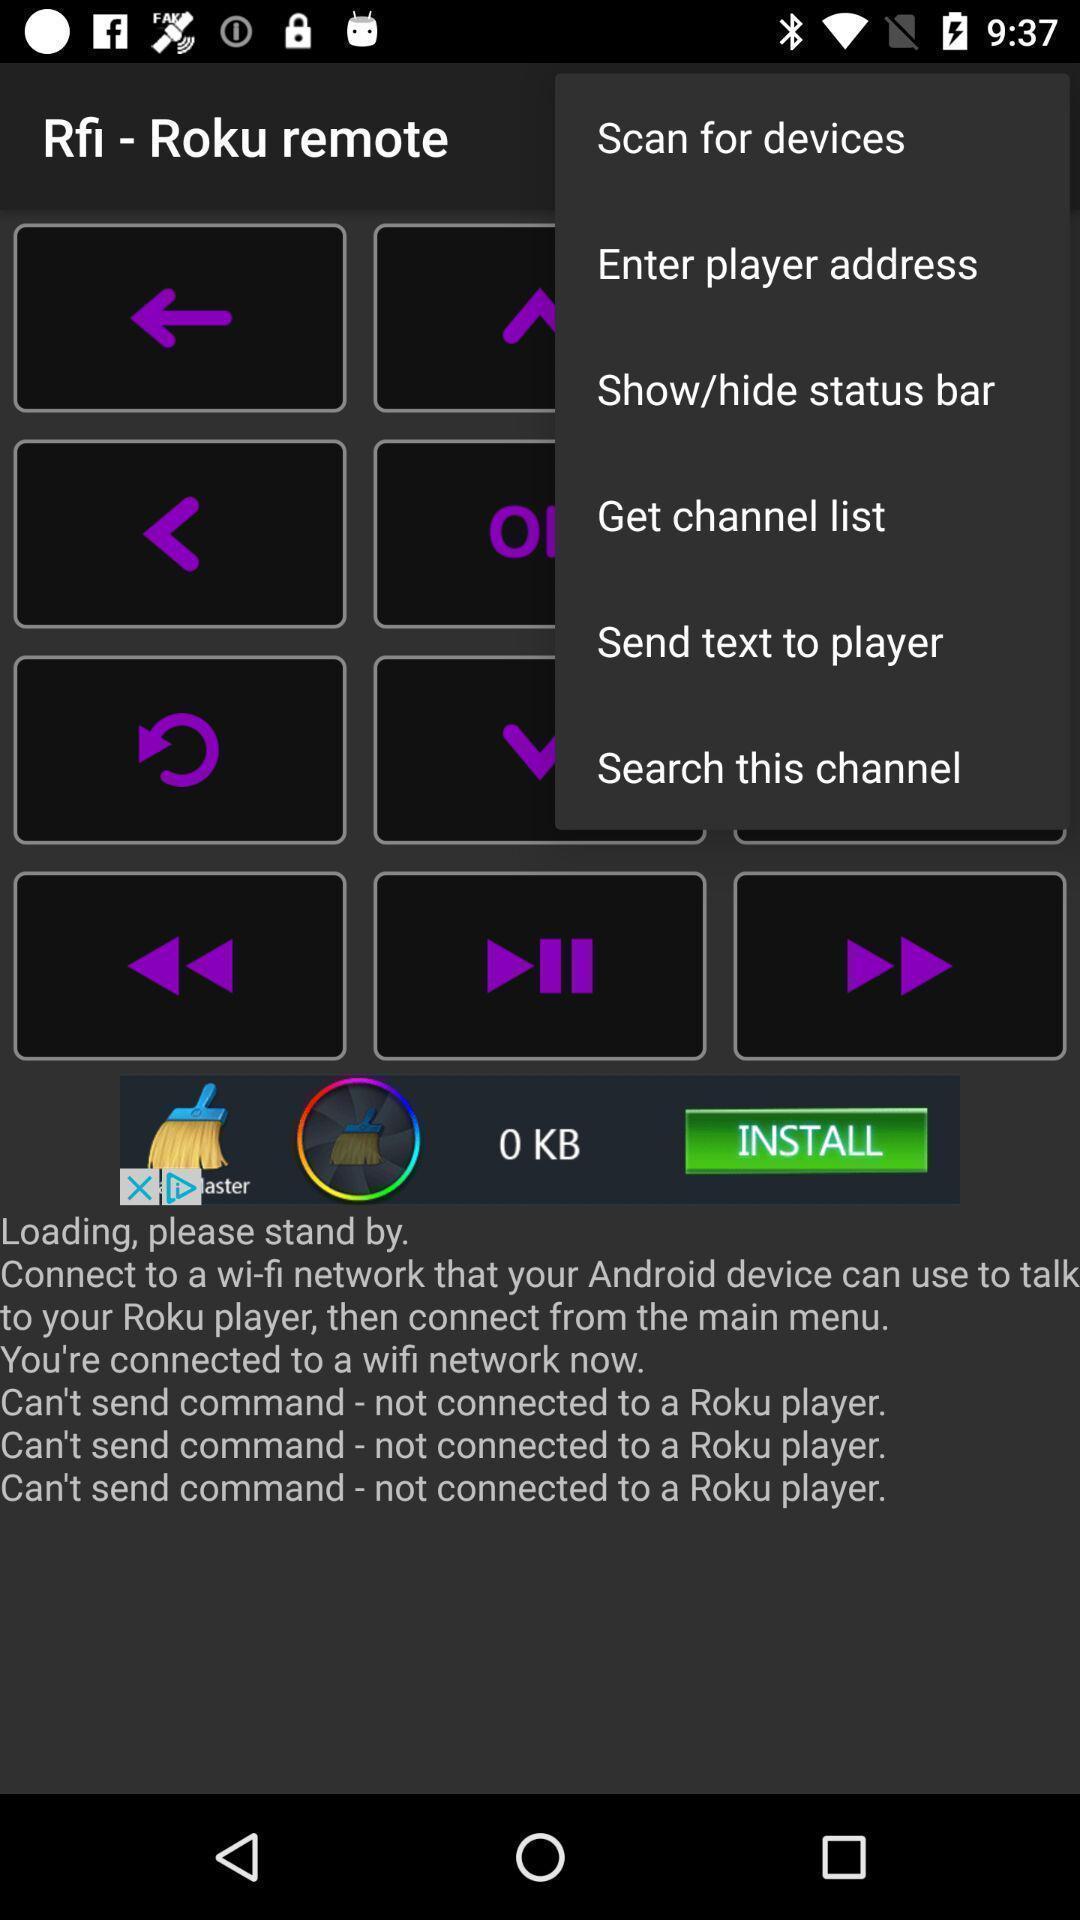Provide a detailed account of this screenshot. Pop up page showing the options in more menu. 